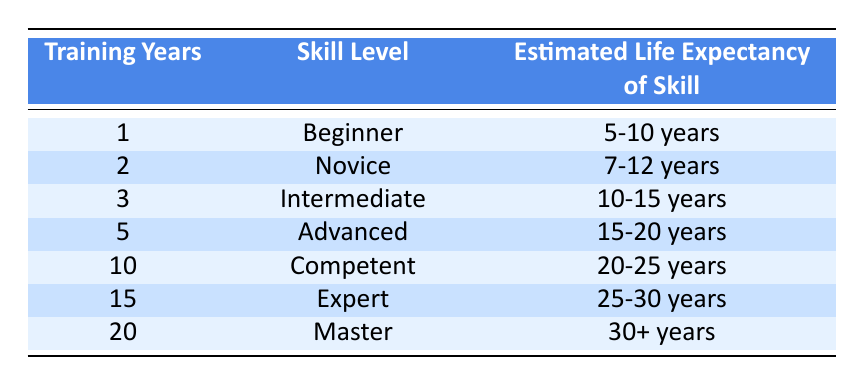What is the estimated life expectancy of skill for an Intermediate rider? To find the answer, refer to the table and locate the row for "Intermediate," which corresponds to 3 training years. The estimated life expectancy of skill for this level is listed as "10-15 years."
Answer: 10-15 years How many years of training are needed to reach the Master skill level? Looking at the table, the Master skill level corresponds to 20 training years.
Answer: 20 years Is the estimated life expectancy of the Novice skill level greater than that of the Beginner skill level? The estimated life expectancy for Novice is "7-12 years," while for Beginner it is "5-10 years." Since the upper limit of Novice (12 years) is greater than the upper limit of Beginner (10 years), the answer is yes.
Answer: Yes What is the difference in the estimated life expectancy of skill between the Advanced and Expert levels? The estimated life expectancy for Advanced is "15-20 years," and for Expert, it is "25-30 years." The average and maximum expected life expectancies for Advanced are 17.5 years and 20 years, respectively, and for Expert, they are 27.5 years and 30 years, respectively. The difference in the maximums is 30 - 20 = 10 years.
Answer: 10 years What would be the average estimated life expectancy of skill across all skill levels listed? To find the average, first determine the range for each skill level and calculate the midpoint: Beginner (7.5), Novice (9.5), Intermediate (12.5), Advanced (17.5), Competent (22.5), Expert (27.5), Master (30). Now, sum them up: 7.5 + 9.5 + 12.5 + 17.5 + 22.5 + 27.5 + 30 = 127.5. Then divide by 7 (total skill levels), resulting in an average of approximately 18.21 years.
Answer: 18.21 years Does an Expert rider have a longer estimated life expectancy of skill than a Novice rider? The Expert skill level has an estimated life expectancy of "25-30 years," while the Novice level has "7-12 years." Since both ranges indicate that the Expert level is significantly higher, the answer is yes.
Answer: Yes 